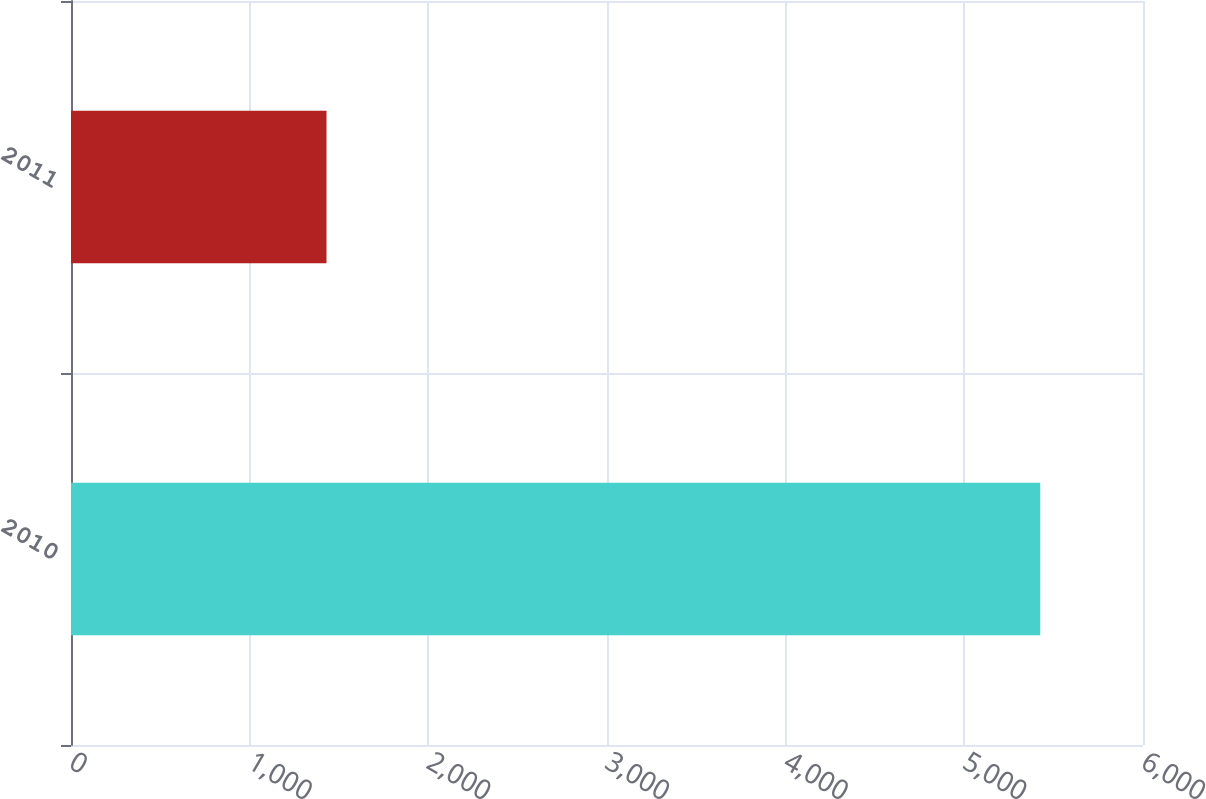Convert chart to OTSL. <chart><loc_0><loc_0><loc_500><loc_500><bar_chart><fcel>2010<fcel>2011<nl><fcel>5425<fcel>1430<nl></chart> 